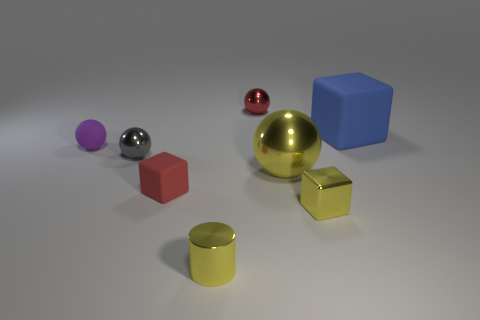Is the color of the big metal object the same as the tiny shiny block?
Your answer should be very brief. Yes. What color is the tiny rubber thing that is the same shape as the big yellow metal thing?
Provide a short and direct response. Purple. There is a metal thing on the left side of the metal cylinder; is its color the same as the metal cube?
Your response must be concise. No. What shape is the big metal thing that is the same color as the tiny metallic cylinder?
Your answer should be compact. Sphere. How many yellow things have the same material as the tiny yellow cylinder?
Your answer should be very brief. 2. There is a small yellow shiny cube; how many yellow blocks are in front of it?
Keep it short and to the point. 0. The yellow block has what size?
Keep it short and to the point. Small. The other block that is the same size as the yellow metal cube is what color?
Make the answer very short. Red. Are there any other big objects of the same color as the large rubber thing?
Your answer should be very brief. No. What is the material of the yellow cylinder?
Your response must be concise. Metal. 